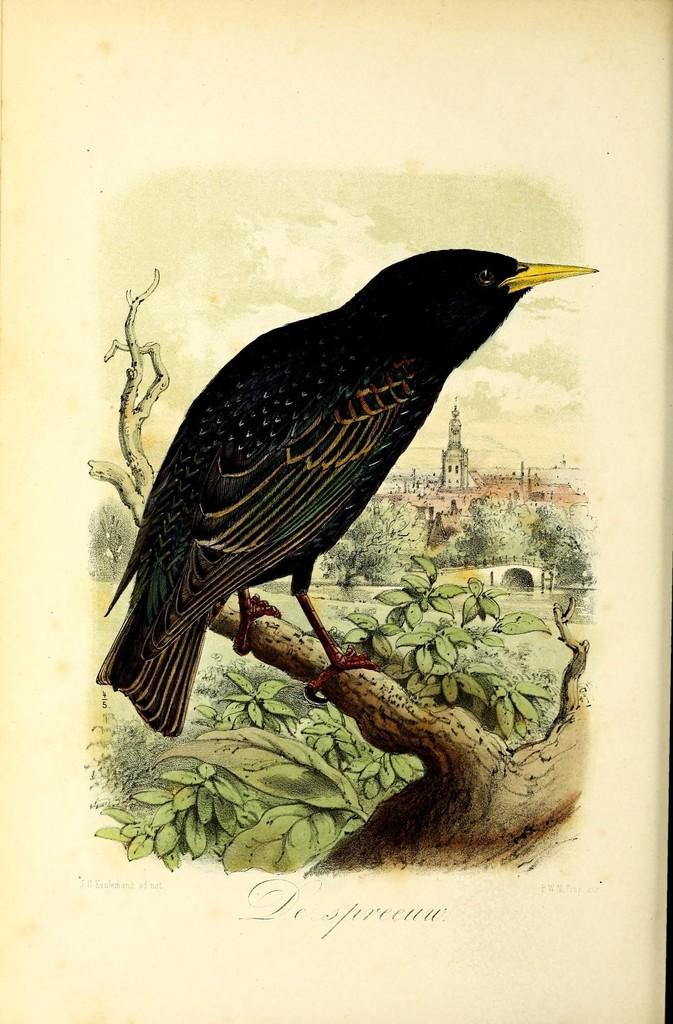What type of animal is in the image? There is a bird in the image. What colors can be seen on the bird? The bird has black, brown, and yellow colors. Where is the bird located in the image? The bird is on the branch of a tree. What can be seen in the background of the image? There are many trees and buildings in the background of the image. What type of jewel is the bird holding in its beak in the image? There is no jewel present in the image; the bird is simply perched on a tree branch. 